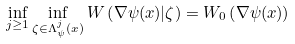Convert formula to latex. <formula><loc_0><loc_0><loc_500><loc_500>\inf _ { j \geq 1 } \inf _ { \zeta \in \Lambda ^ { j } _ { \psi } ( x ) } W \left ( \nabla \psi ( x ) | \zeta \right ) = W _ { 0 } \left ( \nabla \psi ( x ) \right )</formula> 